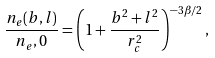<formula> <loc_0><loc_0><loc_500><loc_500>\frac { n _ { e } ( b , l ) } { n _ { e } , 0 } = \left ( 1 + \frac { b ^ { 2 } + l ^ { 2 } } { r _ { c } ^ { 2 } } \right ) ^ { - 3 \beta / 2 } ,</formula> 